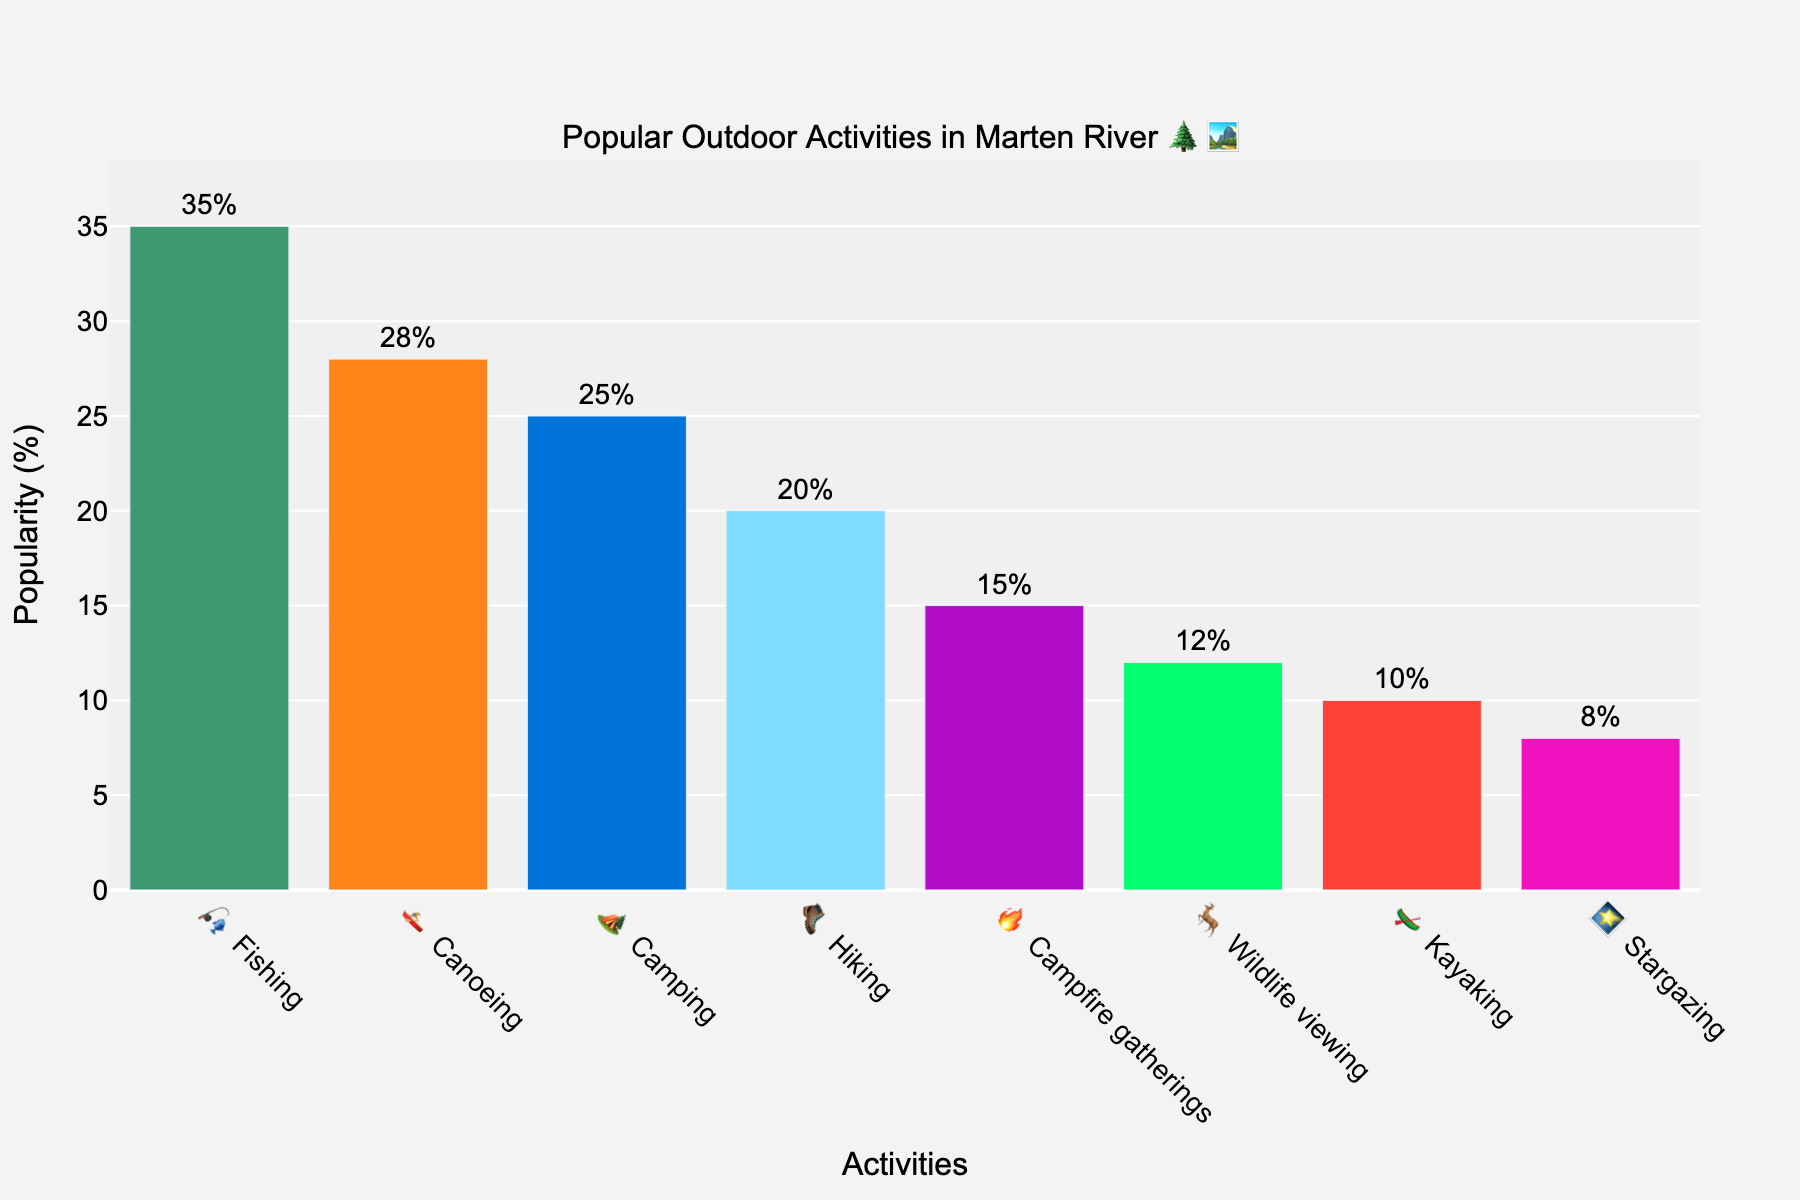What's the most popular activity among Marten River tourists? We look at the bar with the highest value on the y-axis. Fishing has the tallest bar at 35% popularity.
Answer: Fishing Which activity is enjoyed by fewer people, Canoeing or Kayaking? Compare the height of the bars for Canoeing and Kayaking. Canoeing has a popularity of 28%, while Kayaking has 10%.
Answer: Kayaking What is the total popularity percentage for Fishing and Camping combined? Add the popularity percentages for Fishing and Camping. Fishing is 35% and Camping is 25%. 35% + 25% = 60%.
Answer: 60% How many activities have a popularity percentage greater than 20%? Count the bars with a popularity percentage above 20%. Fishing, Canoeing, Camping, and Hiking are above 20%.
Answer: 4 Which activity is least popular among Marten River tourists? Look for the activity with the shortest bar on the y-axis. Stargazing has the lowest popularity at 8%.
Answer: Stargazing Is Hiking more popular than Campfire gatherings? Compare the heights of the bars for Hiking and Campfire gatherings. Hiking has a popularity of 20%, and Campfire gatherings have 15%.
Answer: Yes What's the total popularity of Wildlife viewing, Kayaking, and Stargazing? Add the popularity percentages for Wildlife viewing, Kayaking, and Stargazing. 12% (Wildlife viewing) + 10% (Kayaking) + 8% (Stargazing) = 30%.
Answer: 30% Which activity has around 25% popularity? Identify the bar that has a value close to 25% on the y-axis. Camping has a popularity of 25%.
Answer: Camping Rank the activities from most to least popular based on the chart. List the activities in descending order of their popularity percentages: Fishing (35%), Canoeing (28%), Camping (25%), Hiking (20%), Campfire gatherings (15%), Wildlife viewing (12%), Kayaking (10%), Stargazing (8%).
Answer: Fishing, Canoeing, Camping, Hiking, Campfire gatherings, Wildlife viewing, Kayaking, Stargazing 